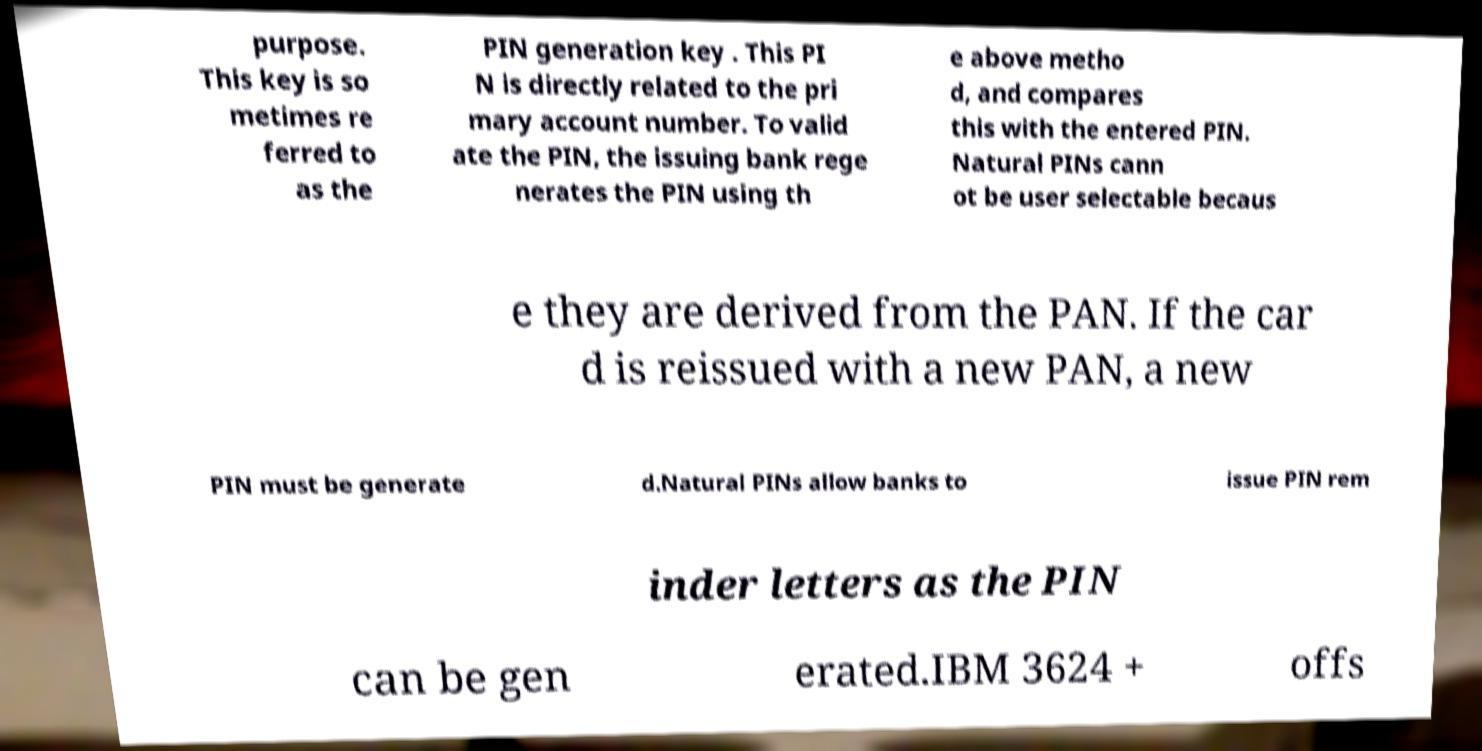Could you assist in decoding the text presented in this image and type it out clearly? purpose. This key is so metimes re ferred to as the PIN generation key . This PI N is directly related to the pri mary account number. To valid ate the PIN, the issuing bank rege nerates the PIN using th e above metho d, and compares this with the entered PIN. Natural PINs cann ot be user selectable becaus e they are derived from the PAN. If the car d is reissued with a new PAN, a new PIN must be generate d.Natural PINs allow banks to issue PIN rem inder letters as the PIN can be gen erated.IBM 3624 + offs 